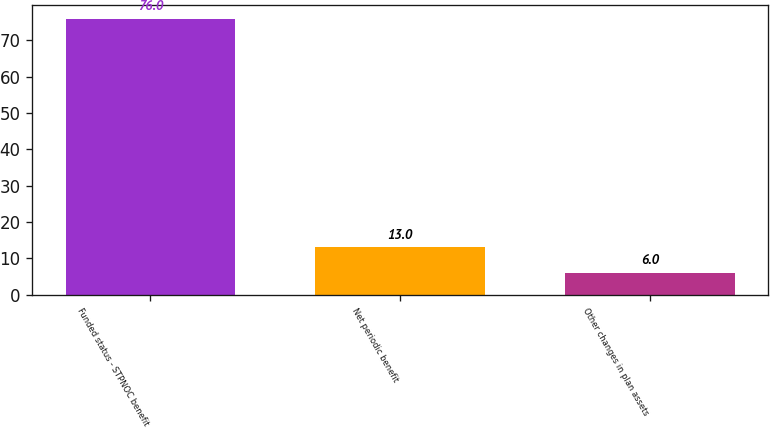Convert chart to OTSL. <chart><loc_0><loc_0><loc_500><loc_500><bar_chart><fcel>Funded status - STPNOC benefit<fcel>Net periodic benefit<fcel>Other changes in plan assets<nl><fcel>76<fcel>13<fcel>6<nl></chart> 